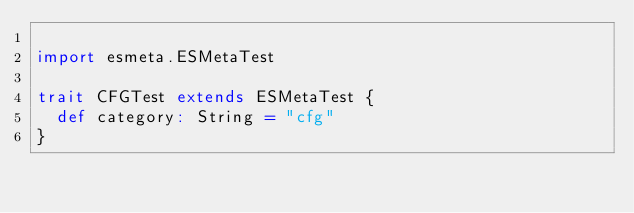<code> <loc_0><loc_0><loc_500><loc_500><_Scala_>
import esmeta.ESMetaTest

trait CFGTest extends ESMetaTest {
  def category: String = "cfg"
}
</code> 